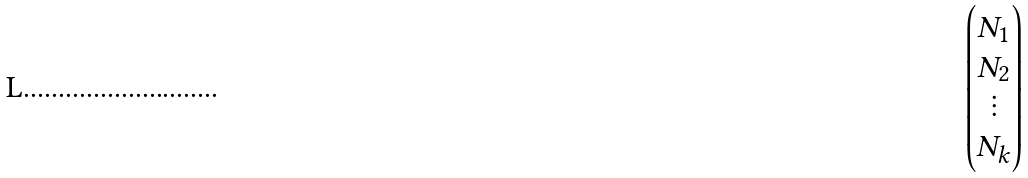Convert formula to latex. <formula><loc_0><loc_0><loc_500><loc_500>\begin{pmatrix} N _ { 1 } \\ N _ { 2 } \\ \vdots \\ N _ { k } \end{pmatrix}</formula> 